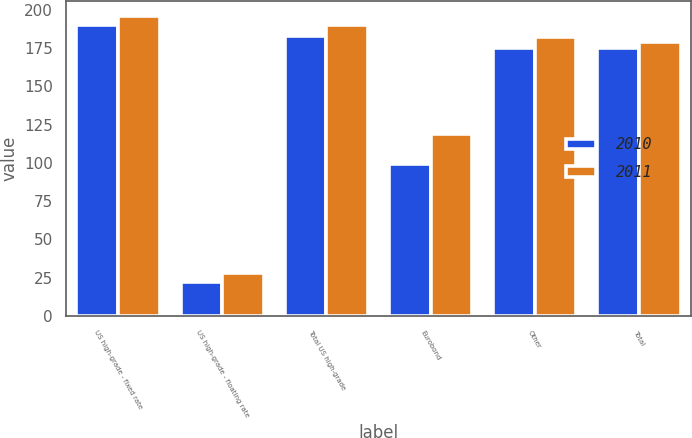<chart> <loc_0><loc_0><loc_500><loc_500><stacked_bar_chart><ecel><fcel>US high-grade - fixed rate<fcel>US high-grade - floating rate<fcel>Total US high-grade<fcel>Eurobond<fcel>Other<fcel>Total<nl><fcel>2010<fcel>190<fcel>22<fcel>183<fcel>99<fcel>175<fcel>175<nl><fcel>2011<fcel>196<fcel>28<fcel>190<fcel>119<fcel>182<fcel>179<nl></chart> 